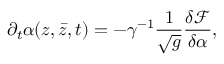<formula> <loc_0><loc_0><loc_500><loc_500>\partial _ { t } \alpha ( z , { \bar { z } } , t ) = - \gamma ^ { - 1 } \frac { 1 } { \sqrt { g } } \frac { \delta \mathcal { F } } { \delta \alpha } ,</formula> 